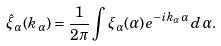<formula> <loc_0><loc_0><loc_500><loc_500>\hat { \xi } _ { \alpha } ( k _ { \alpha } ) = \frac { 1 } { 2 \pi } \int \xi _ { \alpha } ( \alpha ) e ^ { - i k _ { \alpha } \alpha } \, d \alpha .</formula> 